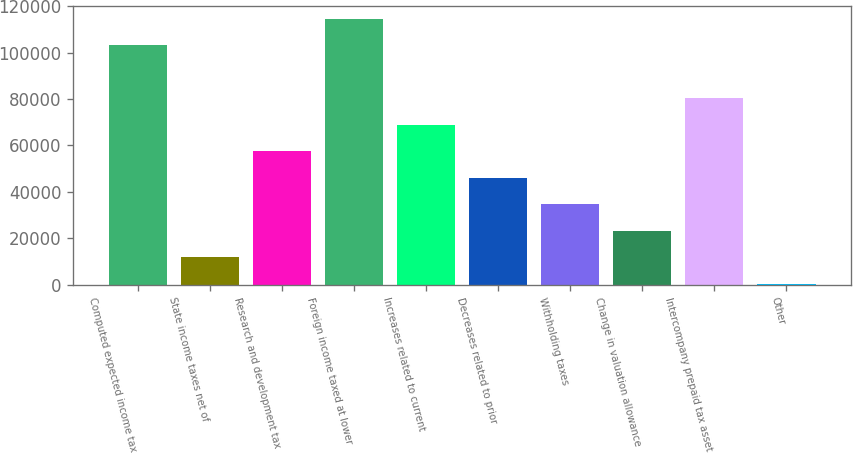Convert chart to OTSL. <chart><loc_0><loc_0><loc_500><loc_500><bar_chart><fcel>Computed expected income tax<fcel>State income taxes net of<fcel>Research and development tax<fcel>Foreign income taxed at lower<fcel>Increases related to current<fcel>Decreases related to prior<fcel>Withholding taxes<fcel>Change in valuation allowance<fcel>Intercompany prepaid tax asset<fcel>Other<nl><fcel>103083<fcel>11771<fcel>57427<fcel>114497<fcel>68841<fcel>46013<fcel>34599<fcel>23185<fcel>80255<fcel>357<nl></chart> 